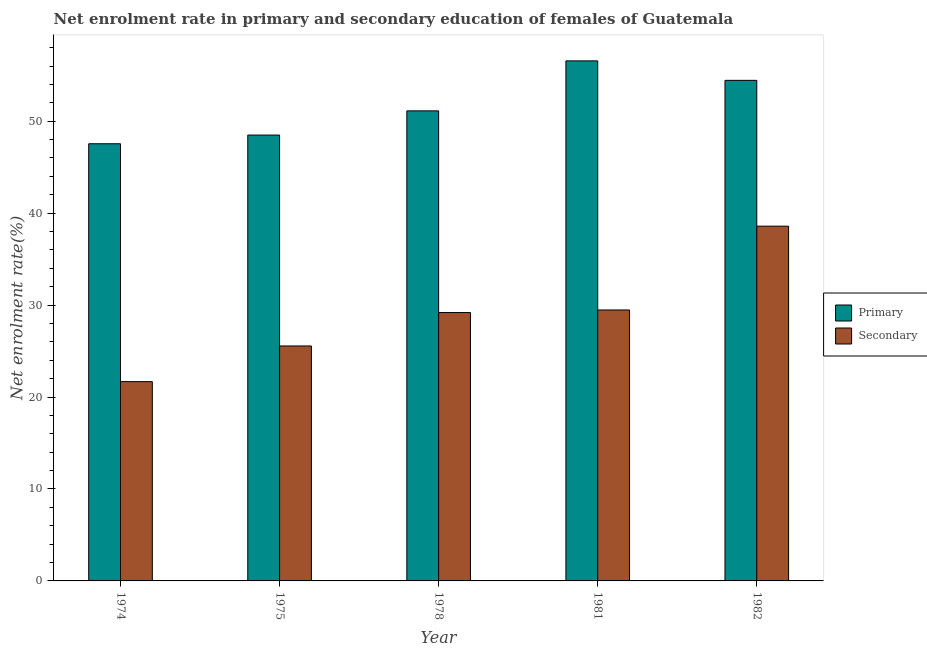How many groups of bars are there?
Offer a terse response. 5. Are the number of bars on each tick of the X-axis equal?
Ensure brevity in your answer.  Yes. What is the label of the 3rd group of bars from the left?
Offer a very short reply. 1978. In how many cases, is the number of bars for a given year not equal to the number of legend labels?
Make the answer very short. 0. What is the enrollment rate in primary education in 1982?
Ensure brevity in your answer.  54.44. Across all years, what is the maximum enrollment rate in secondary education?
Make the answer very short. 38.58. Across all years, what is the minimum enrollment rate in secondary education?
Make the answer very short. 21.68. In which year was the enrollment rate in primary education maximum?
Keep it short and to the point. 1981. In which year was the enrollment rate in primary education minimum?
Offer a very short reply. 1974. What is the total enrollment rate in primary education in the graph?
Your response must be concise. 258.16. What is the difference between the enrollment rate in primary education in 1975 and that in 1982?
Provide a succinct answer. -5.95. What is the difference between the enrollment rate in secondary education in 1978 and the enrollment rate in primary education in 1981?
Give a very brief answer. -0.28. What is the average enrollment rate in primary education per year?
Ensure brevity in your answer.  51.63. In the year 1975, what is the difference between the enrollment rate in primary education and enrollment rate in secondary education?
Offer a very short reply. 0. What is the ratio of the enrollment rate in secondary education in 1974 to that in 1978?
Give a very brief answer. 0.74. What is the difference between the highest and the second highest enrollment rate in primary education?
Ensure brevity in your answer.  2.12. What is the difference between the highest and the lowest enrollment rate in primary education?
Ensure brevity in your answer.  9.01. In how many years, is the enrollment rate in primary education greater than the average enrollment rate in primary education taken over all years?
Your answer should be very brief. 2. What does the 2nd bar from the left in 1982 represents?
Your answer should be compact. Secondary. What does the 2nd bar from the right in 1978 represents?
Offer a terse response. Primary. How many years are there in the graph?
Offer a terse response. 5. What is the difference between two consecutive major ticks on the Y-axis?
Give a very brief answer. 10. How are the legend labels stacked?
Provide a succinct answer. Vertical. What is the title of the graph?
Offer a terse response. Net enrolment rate in primary and secondary education of females of Guatemala. What is the label or title of the X-axis?
Keep it short and to the point. Year. What is the label or title of the Y-axis?
Your answer should be very brief. Net enrolment rate(%). What is the Net enrolment rate(%) in Primary in 1974?
Make the answer very short. 47.55. What is the Net enrolment rate(%) of Secondary in 1974?
Keep it short and to the point. 21.68. What is the Net enrolment rate(%) in Primary in 1975?
Ensure brevity in your answer.  48.49. What is the Net enrolment rate(%) in Secondary in 1975?
Your response must be concise. 25.55. What is the Net enrolment rate(%) of Primary in 1978?
Give a very brief answer. 51.12. What is the Net enrolment rate(%) in Secondary in 1978?
Make the answer very short. 29.19. What is the Net enrolment rate(%) of Primary in 1981?
Offer a very short reply. 56.56. What is the Net enrolment rate(%) of Secondary in 1981?
Make the answer very short. 29.47. What is the Net enrolment rate(%) of Primary in 1982?
Your answer should be compact. 54.44. What is the Net enrolment rate(%) in Secondary in 1982?
Provide a succinct answer. 38.58. Across all years, what is the maximum Net enrolment rate(%) in Primary?
Your response must be concise. 56.56. Across all years, what is the maximum Net enrolment rate(%) in Secondary?
Provide a short and direct response. 38.58. Across all years, what is the minimum Net enrolment rate(%) in Primary?
Give a very brief answer. 47.55. Across all years, what is the minimum Net enrolment rate(%) of Secondary?
Offer a terse response. 21.68. What is the total Net enrolment rate(%) in Primary in the graph?
Offer a very short reply. 258.16. What is the total Net enrolment rate(%) of Secondary in the graph?
Your response must be concise. 144.47. What is the difference between the Net enrolment rate(%) in Primary in 1974 and that in 1975?
Give a very brief answer. -0.94. What is the difference between the Net enrolment rate(%) in Secondary in 1974 and that in 1975?
Your answer should be very brief. -3.88. What is the difference between the Net enrolment rate(%) of Primary in 1974 and that in 1978?
Give a very brief answer. -3.58. What is the difference between the Net enrolment rate(%) in Secondary in 1974 and that in 1978?
Your answer should be compact. -7.51. What is the difference between the Net enrolment rate(%) in Primary in 1974 and that in 1981?
Your answer should be very brief. -9.01. What is the difference between the Net enrolment rate(%) of Secondary in 1974 and that in 1981?
Keep it short and to the point. -7.79. What is the difference between the Net enrolment rate(%) in Primary in 1974 and that in 1982?
Make the answer very short. -6.9. What is the difference between the Net enrolment rate(%) of Secondary in 1974 and that in 1982?
Provide a succinct answer. -16.91. What is the difference between the Net enrolment rate(%) of Primary in 1975 and that in 1978?
Offer a terse response. -2.63. What is the difference between the Net enrolment rate(%) in Secondary in 1975 and that in 1978?
Offer a terse response. -3.63. What is the difference between the Net enrolment rate(%) in Primary in 1975 and that in 1981?
Provide a short and direct response. -8.07. What is the difference between the Net enrolment rate(%) in Secondary in 1975 and that in 1981?
Give a very brief answer. -3.91. What is the difference between the Net enrolment rate(%) in Primary in 1975 and that in 1982?
Make the answer very short. -5.95. What is the difference between the Net enrolment rate(%) of Secondary in 1975 and that in 1982?
Your answer should be very brief. -13.03. What is the difference between the Net enrolment rate(%) of Primary in 1978 and that in 1981?
Your response must be concise. -5.44. What is the difference between the Net enrolment rate(%) of Secondary in 1978 and that in 1981?
Provide a short and direct response. -0.28. What is the difference between the Net enrolment rate(%) of Primary in 1978 and that in 1982?
Provide a short and direct response. -3.32. What is the difference between the Net enrolment rate(%) of Secondary in 1978 and that in 1982?
Provide a short and direct response. -9.39. What is the difference between the Net enrolment rate(%) in Primary in 1981 and that in 1982?
Offer a very short reply. 2.12. What is the difference between the Net enrolment rate(%) in Secondary in 1981 and that in 1982?
Your answer should be compact. -9.11. What is the difference between the Net enrolment rate(%) in Primary in 1974 and the Net enrolment rate(%) in Secondary in 1975?
Make the answer very short. 21.99. What is the difference between the Net enrolment rate(%) of Primary in 1974 and the Net enrolment rate(%) of Secondary in 1978?
Offer a terse response. 18.36. What is the difference between the Net enrolment rate(%) in Primary in 1974 and the Net enrolment rate(%) in Secondary in 1981?
Provide a succinct answer. 18.08. What is the difference between the Net enrolment rate(%) in Primary in 1974 and the Net enrolment rate(%) in Secondary in 1982?
Provide a succinct answer. 8.96. What is the difference between the Net enrolment rate(%) in Primary in 1975 and the Net enrolment rate(%) in Secondary in 1978?
Your response must be concise. 19.3. What is the difference between the Net enrolment rate(%) of Primary in 1975 and the Net enrolment rate(%) of Secondary in 1981?
Your answer should be compact. 19.02. What is the difference between the Net enrolment rate(%) of Primary in 1975 and the Net enrolment rate(%) of Secondary in 1982?
Provide a succinct answer. 9.91. What is the difference between the Net enrolment rate(%) of Primary in 1978 and the Net enrolment rate(%) of Secondary in 1981?
Offer a terse response. 21.65. What is the difference between the Net enrolment rate(%) in Primary in 1978 and the Net enrolment rate(%) in Secondary in 1982?
Keep it short and to the point. 12.54. What is the difference between the Net enrolment rate(%) of Primary in 1981 and the Net enrolment rate(%) of Secondary in 1982?
Offer a terse response. 17.98. What is the average Net enrolment rate(%) of Primary per year?
Keep it short and to the point. 51.63. What is the average Net enrolment rate(%) of Secondary per year?
Provide a short and direct response. 28.89. In the year 1974, what is the difference between the Net enrolment rate(%) in Primary and Net enrolment rate(%) in Secondary?
Offer a terse response. 25.87. In the year 1975, what is the difference between the Net enrolment rate(%) in Primary and Net enrolment rate(%) in Secondary?
Provide a short and direct response. 22.94. In the year 1978, what is the difference between the Net enrolment rate(%) in Primary and Net enrolment rate(%) in Secondary?
Your response must be concise. 21.93. In the year 1981, what is the difference between the Net enrolment rate(%) in Primary and Net enrolment rate(%) in Secondary?
Provide a succinct answer. 27.09. In the year 1982, what is the difference between the Net enrolment rate(%) in Primary and Net enrolment rate(%) in Secondary?
Provide a short and direct response. 15.86. What is the ratio of the Net enrolment rate(%) of Primary in 1974 to that in 1975?
Offer a terse response. 0.98. What is the ratio of the Net enrolment rate(%) in Secondary in 1974 to that in 1975?
Give a very brief answer. 0.85. What is the ratio of the Net enrolment rate(%) in Secondary in 1974 to that in 1978?
Offer a very short reply. 0.74. What is the ratio of the Net enrolment rate(%) of Primary in 1974 to that in 1981?
Make the answer very short. 0.84. What is the ratio of the Net enrolment rate(%) in Secondary in 1974 to that in 1981?
Offer a very short reply. 0.74. What is the ratio of the Net enrolment rate(%) of Primary in 1974 to that in 1982?
Give a very brief answer. 0.87. What is the ratio of the Net enrolment rate(%) of Secondary in 1974 to that in 1982?
Give a very brief answer. 0.56. What is the ratio of the Net enrolment rate(%) of Primary in 1975 to that in 1978?
Provide a succinct answer. 0.95. What is the ratio of the Net enrolment rate(%) of Secondary in 1975 to that in 1978?
Ensure brevity in your answer.  0.88. What is the ratio of the Net enrolment rate(%) in Primary in 1975 to that in 1981?
Your response must be concise. 0.86. What is the ratio of the Net enrolment rate(%) of Secondary in 1975 to that in 1981?
Your response must be concise. 0.87. What is the ratio of the Net enrolment rate(%) in Primary in 1975 to that in 1982?
Your response must be concise. 0.89. What is the ratio of the Net enrolment rate(%) in Secondary in 1975 to that in 1982?
Give a very brief answer. 0.66. What is the ratio of the Net enrolment rate(%) in Primary in 1978 to that in 1981?
Provide a succinct answer. 0.9. What is the ratio of the Net enrolment rate(%) of Primary in 1978 to that in 1982?
Offer a very short reply. 0.94. What is the ratio of the Net enrolment rate(%) of Secondary in 1978 to that in 1982?
Provide a succinct answer. 0.76. What is the ratio of the Net enrolment rate(%) of Primary in 1981 to that in 1982?
Provide a short and direct response. 1.04. What is the ratio of the Net enrolment rate(%) in Secondary in 1981 to that in 1982?
Provide a short and direct response. 0.76. What is the difference between the highest and the second highest Net enrolment rate(%) of Primary?
Your answer should be compact. 2.12. What is the difference between the highest and the second highest Net enrolment rate(%) of Secondary?
Make the answer very short. 9.11. What is the difference between the highest and the lowest Net enrolment rate(%) of Primary?
Offer a very short reply. 9.01. What is the difference between the highest and the lowest Net enrolment rate(%) of Secondary?
Your answer should be compact. 16.91. 